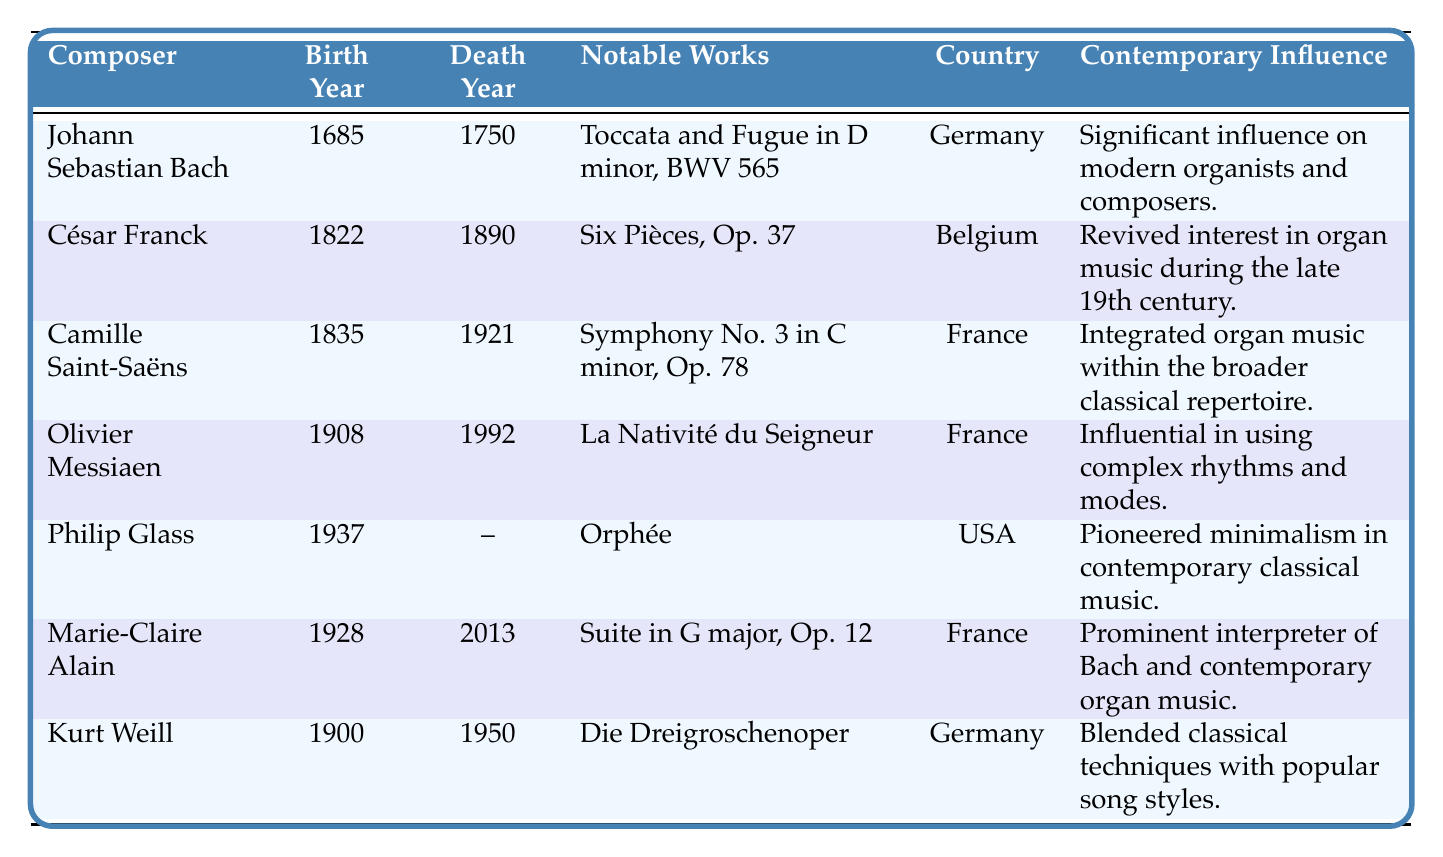What is the birth year of Johann Sebastian Bach? The table lists Johann Sebastian Bach in the first row, where the birth year is indicated in the second column. It shows 1685 as the birth year.
Answer: 1685 Which composer was born in 1937? The table provides information about several composers, and the birth years can be found in the second column. The composer listed with the birth year of 1937 is Philip Glass.
Answer: Philip Glass How many notable works does Olivier Messiaen have listed? By looking at the row for Olivier Messiaen in the table, we can count the notable works listed under the fourth column. There are three notable works mentioned: "La Nativité du Seigneur," "Les Corps Glorieux," and "L'Ascension."
Answer: 3 Which country does César Franck come from? César Franck's country can be found in the fifth column of the corresponding row in the table, which specifies Belgium.
Answer: Belgium Did any composers in the table die before 1950? The table shows the death years for several composers. By reviewing the fourth column, we can see that Bach, Franck, Saint-Saëns, Messiaen, and Weill all died before 1950.
Answer: Yes What is the contemporary influence of Philip Glass? Philip Glass’s contemporary influence is outlined in the last column. It states that he "pioneered minimalism in contemporary classical music."
Answer: Pioneered minimalism in contemporary classical music How many composers are from France? From the table, we can count the entries that list France in the country column. There are three composers from France: Camille Saint-Saëns, Olivier Messiaen, and Marie-Claire Alain.
Answer: 3 Which composer listed has the greatest range of years spanning their life? By comparing the birth and death years of each composer, we can calculate the lifespan of each. Jacques Franck lived from 1822 to 1890, which gives a lifespan of 68 years. Bach lived from 1685 to 1750 (65 years). Saint-Saëns (1835-1921, 86 years), Messiaen (1908-1992, 84 years), Glass (1937-present, lifetime), Alain (1928-2013, 85 years), and Weill (1900-1950, 50 years). The greatest documented lifespan is from Saint-Saëns.
Answer: Camille Saint-Saëns Are there any composers in the table who do not have a listed death year? By examining the death years in the table, Philip Glass is the only composer without a listed death year, indicated by "–."
Answer: Yes What notable work did Kurt Weill compose? The notable works for Kurt Weill are listed in the fourth column, where it shows "Die Dreigroschenoper," "L'Opéra de Quat'Sous," and "Symphonic Suite." One notable work is "Die Dreigroschenoper."
Answer: Die Dreigroschenoper 